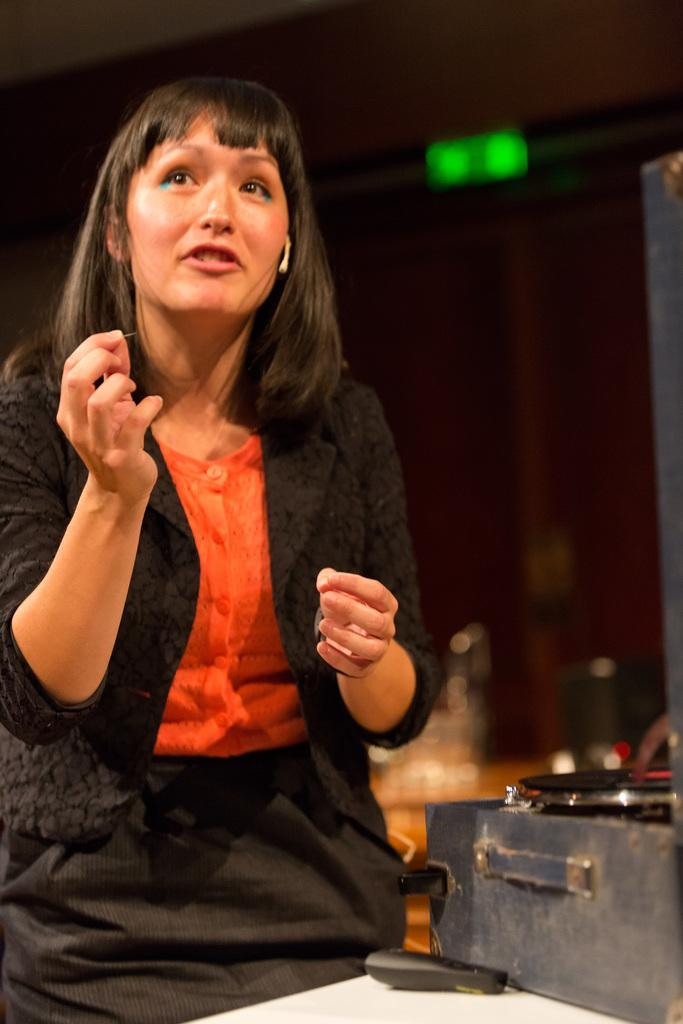Who is on the left side of the image? There is a woman on the left side of the image. What is the woman wearing? The woman is wearing a black color jacket. What is the woman doing in the image? The woman is speaking. What can be seen on the right side of the image? There is a box on the right side of the image. What object is on the table in the image? There is a remote on a table in the image. How would you describe the background of the image? The background of the image is blurred. Who is the owner of the tomatoes in the image? There are no tomatoes present in the image, so it is not possible to determine the owner. 